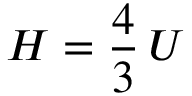Convert formula to latex. <formula><loc_0><loc_0><loc_500><loc_500>H = { \frac { 4 } { 3 } } \, U</formula> 